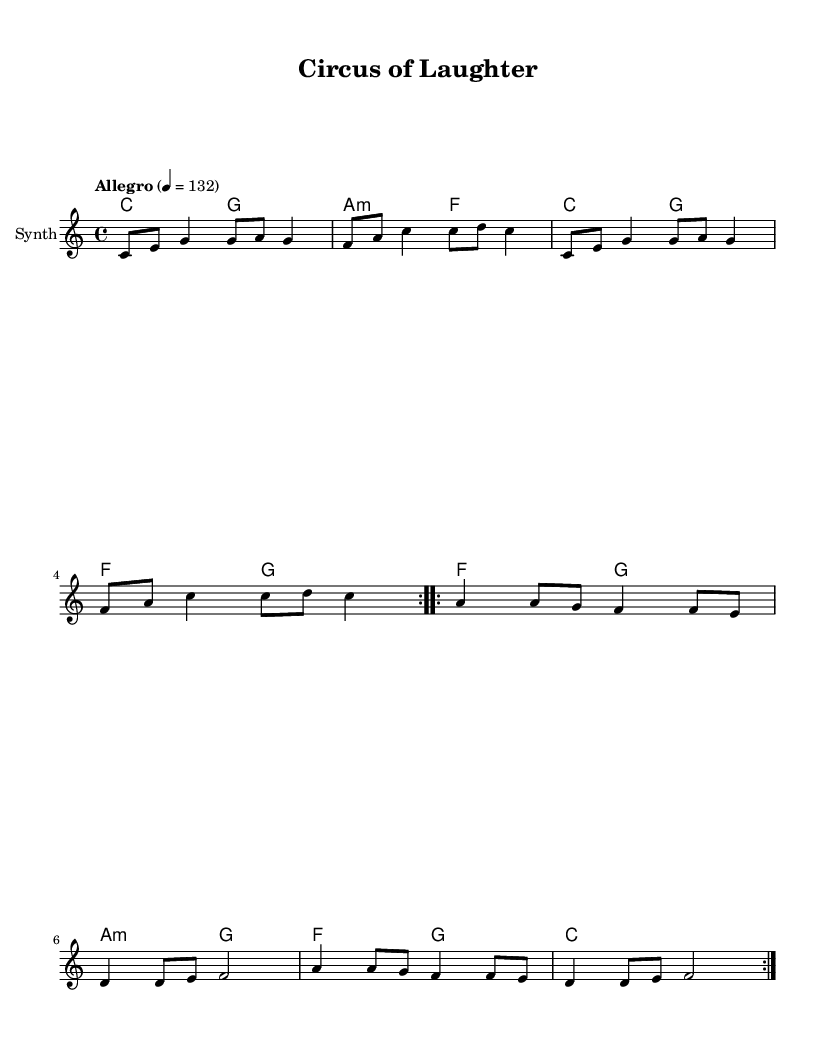What is the key signature of this music? The key signature is C major, which has no sharps or flats.
Answer: C major What is the time signature of this music? The time signature is indicated as 4/4, meaning there are four beats in each measure.
Answer: 4/4 What is the tempo marking for this piece? The tempo marking specified is "Allegro" at 132 beats per minute, indicating a fast-paced tempo.
Answer: Allegro How many times is the first section repeated? The first section of the melody, indicated by the repeat volta, is repeated two times.
Answer: 2 What is the name of the instrument indicated in the score? The instrument indicated for this piece is labeled as "Synth" in the staff notation.
Answer: Synth In the chorus, which word rhymes with "laughter"? The word "after" in the chorus lyrics rhymes with "laughter."
Answer: after What is the chord progression for the first four measures? The chord progression for the first four measures is C to G to A minor to F.
Answer: C G A minor F 